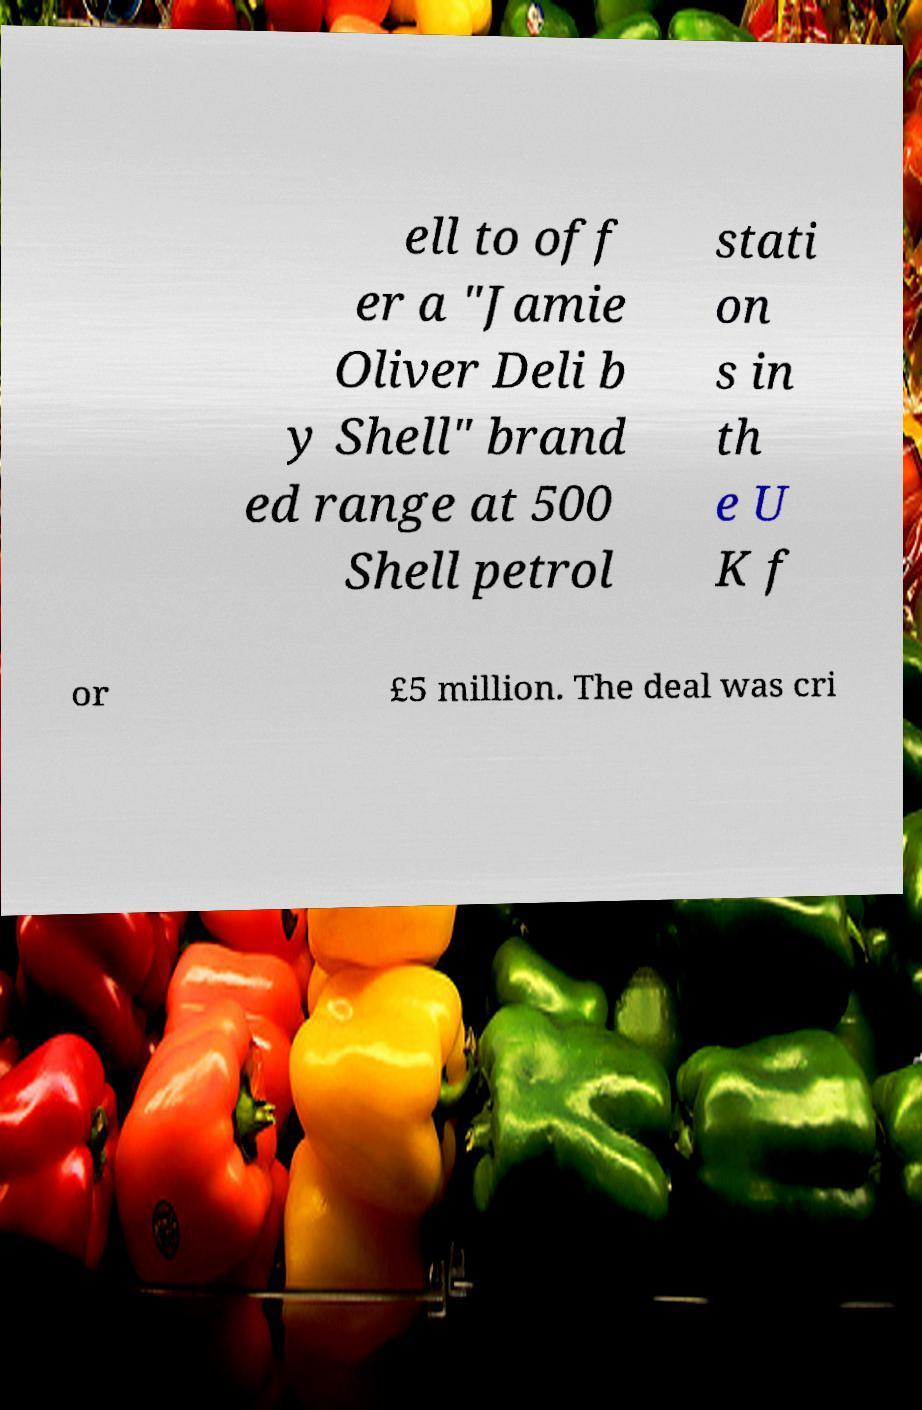Can you accurately transcribe the text from the provided image for me? ell to off er a "Jamie Oliver Deli b y Shell" brand ed range at 500 Shell petrol stati on s in th e U K f or £5 million. The deal was cri 